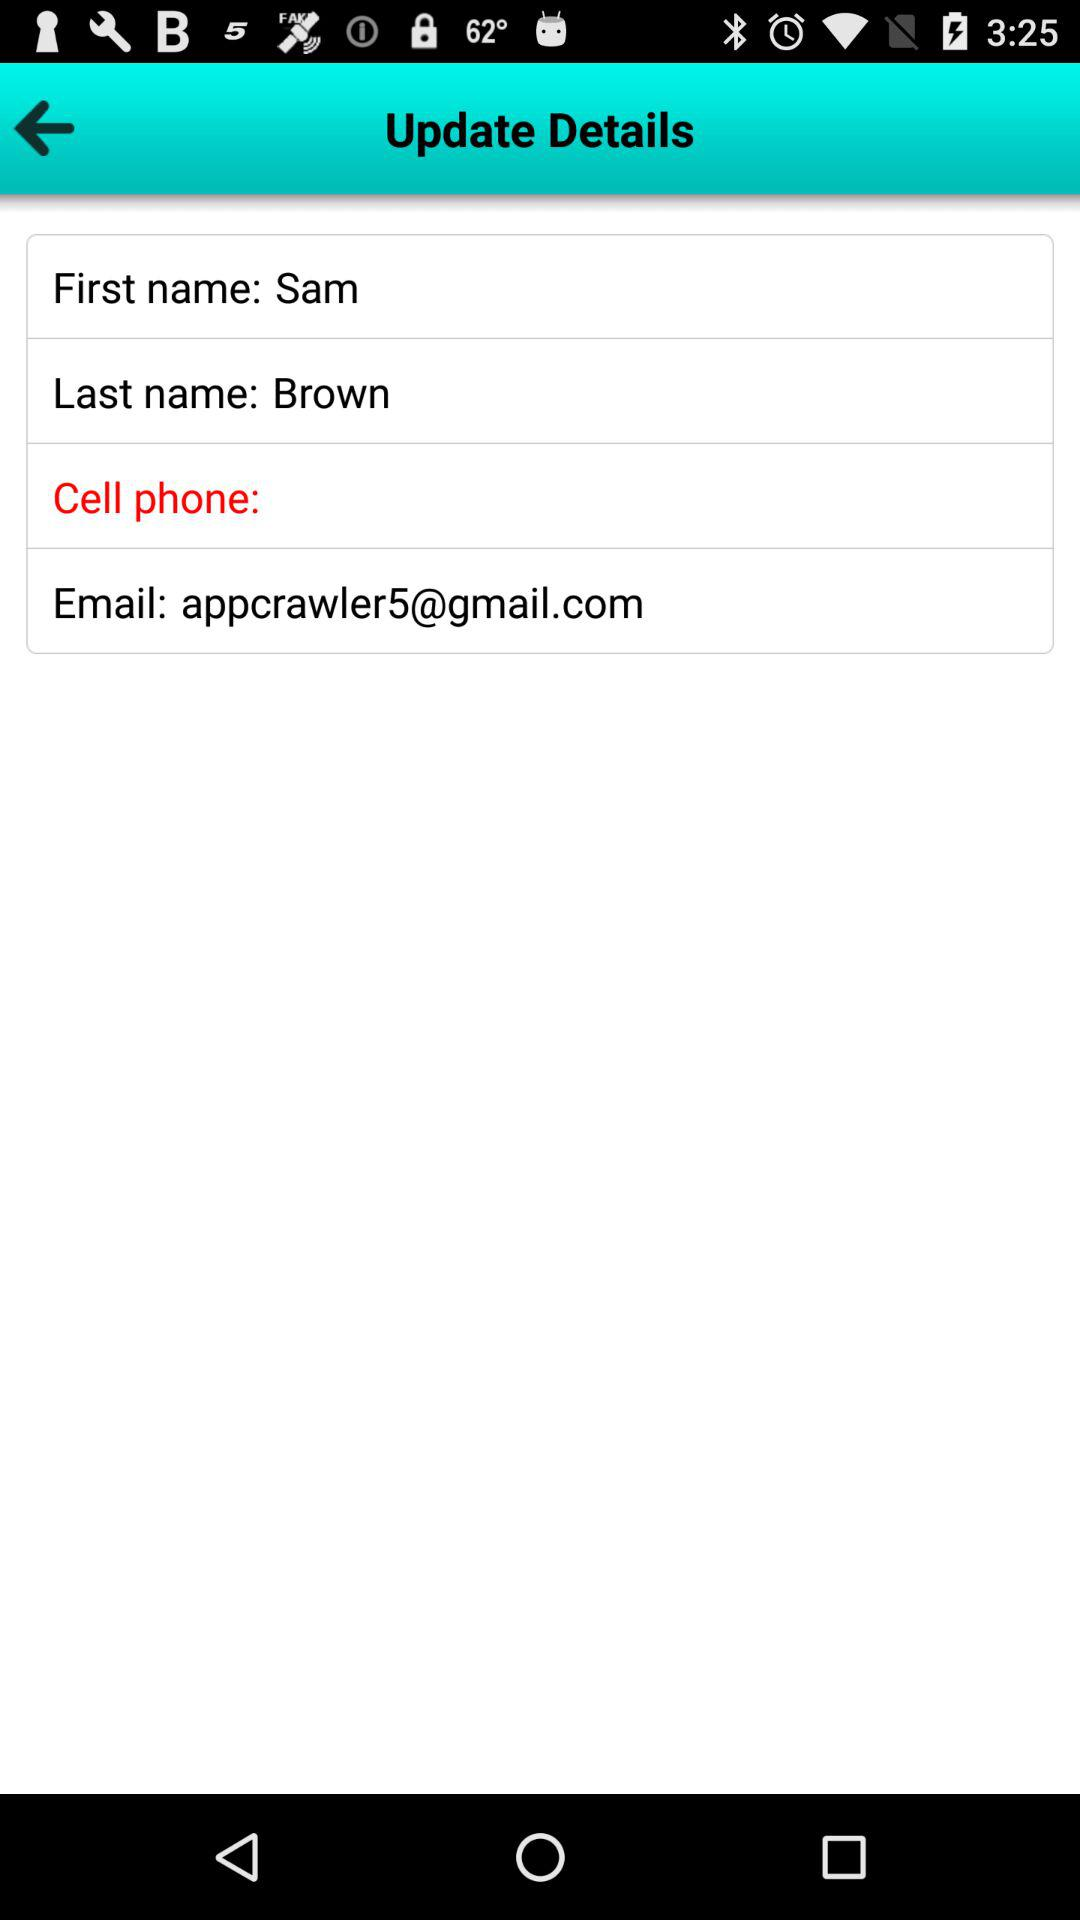What is the first name of the user? The first name of the user is Sam. 